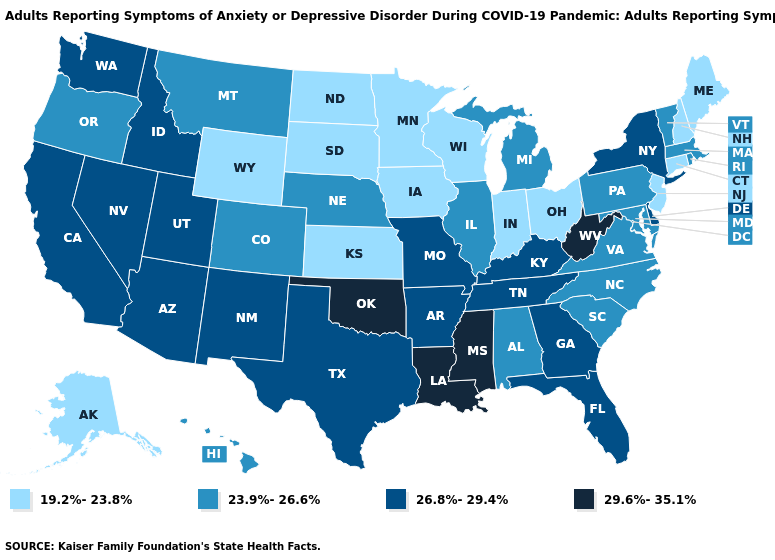Name the states that have a value in the range 23.9%-26.6%?
Concise answer only. Alabama, Colorado, Hawaii, Illinois, Maryland, Massachusetts, Michigan, Montana, Nebraska, North Carolina, Oregon, Pennsylvania, Rhode Island, South Carolina, Vermont, Virginia. Does Oklahoma have the highest value in the South?
Keep it brief. Yes. What is the value of Mississippi?
Concise answer only. 29.6%-35.1%. What is the value of Louisiana?
Concise answer only. 29.6%-35.1%. Does Texas have a lower value than Indiana?
Short answer required. No. What is the lowest value in the USA?
Be succinct. 19.2%-23.8%. What is the value of Arizona?
Quick response, please. 26.8%-29.4%. Does Vermont have a higher value than North Dakota?
Short answer required. Yes. Among the states that border Wyoming , does South Dakota have the lowest value?
Answer briefly. Yes. What is the lowest value in the USA?
Write a very short answer. 19.2%-23.8%. Among the states that border Utah , which have the highest value?
Write a very short answer. Arizona, Idaho, Nevada, New Mexico. What is the value of Colorado?
Be succinct. 23.9%-26.6%. What is the value of Oregon?
Be succinct. 23.9%-26.6%. Does New Mexico have the highest value in the USA?
Answer briefly. No. Which states have the lowest value in the USA?
Quick response, please. Alaska, Connecticut, Indiana, Iowa, Kansas, Maine, Minnesota, New Hampshire, New Jersey, North Dakota, Ohio, South Dakota, Wisconsin, Wyoming. 